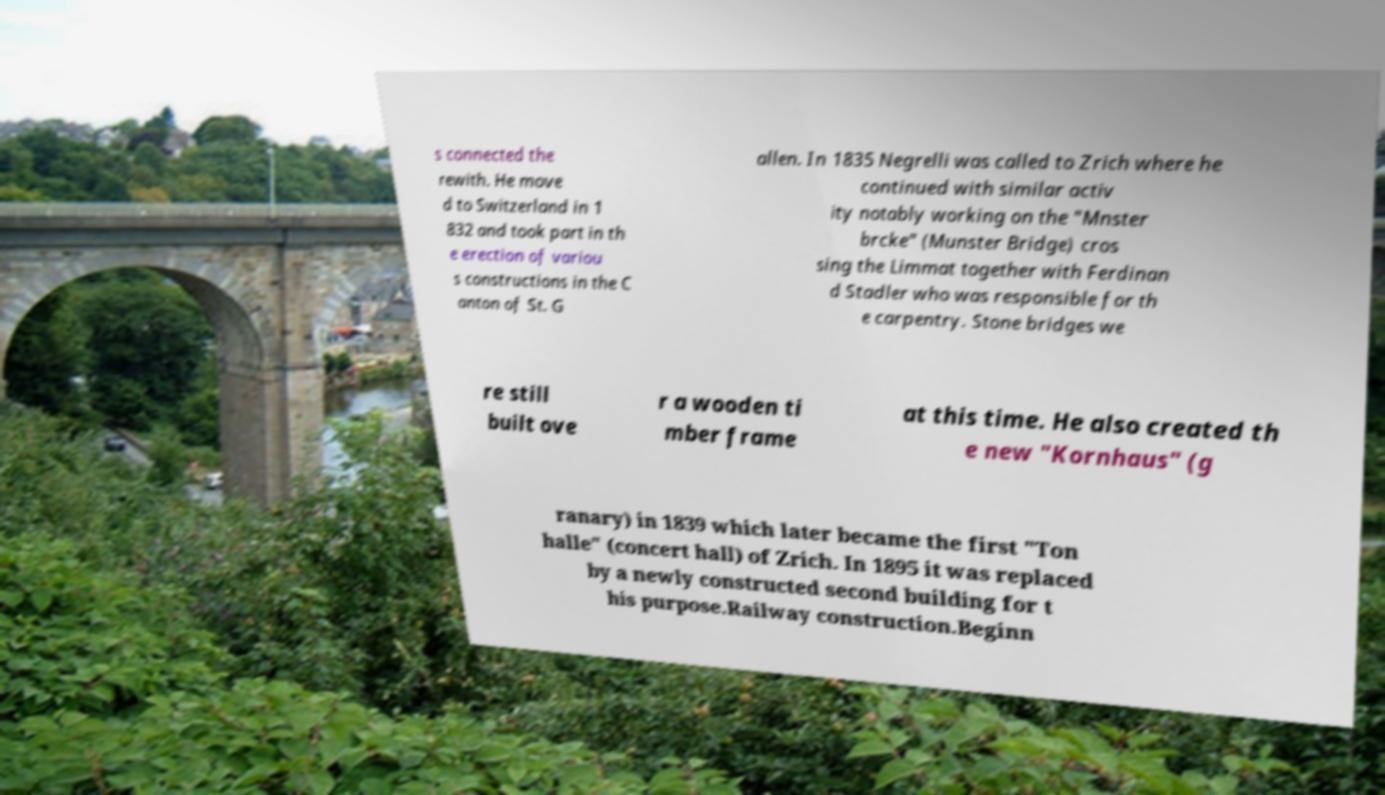For documentation purposes, I need the text within this image transcribed. Could you provide that? s connected the rewith. He move d to Switzerland in 1 832 and took part in th e erection of variou s constructions in the C anton of St. G allen. In 1835 Negrelli was called to Zrich where he continued with similar activ ity notably working on the "Mnster brcke" (Munster Bridge) cros sing the Limmat together with Ferdinan d Stadler who was responsible for th e carpentry. Stone bridges we re still built ove r a wooden ti mber frame at this time. He also created th e new "Kornhaus" (g ranary) in 1839 which later became the first "Ton halle" (concert hall) of Zrich. In 1895 it was replaced by a newly constructed second building for t his purpose.Railway construction.Beginn 